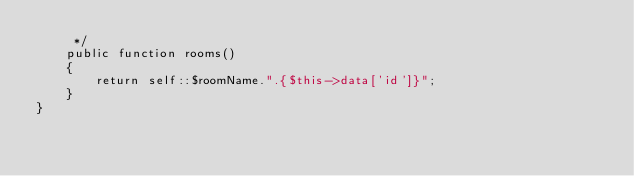<code> <loc_0><loc_0><loc_500><loc_500><_PHP_>     */
    public function rooms()
    {
        return self::$roomName.".{$this->data['id']}";
    }
}
</code> 